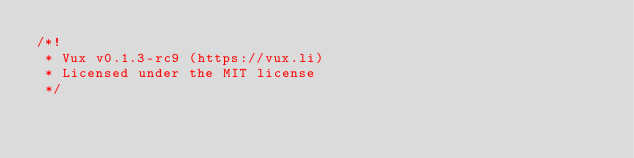Convert code to text. <code><loc_0><loc_0><loc_500><loc_500><_JavaScript_>/*!
 * Vux v0.1.3-rc9 (https://vux.li)
 * Licensed under the MIT license
 */</code> 